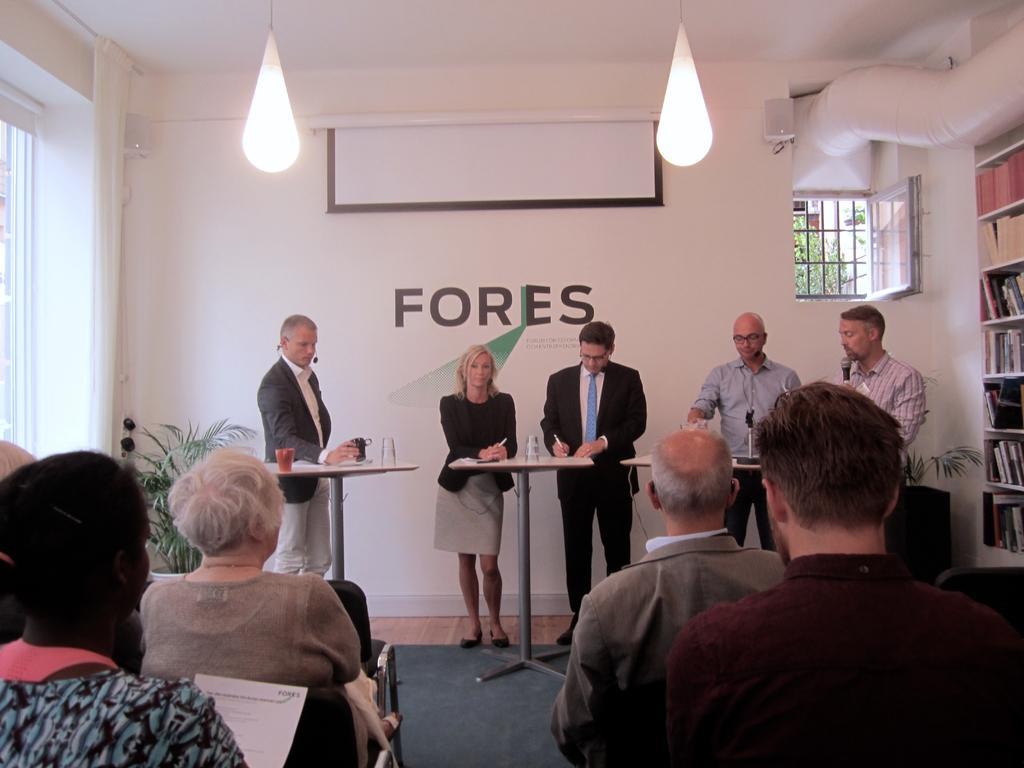In one or two sentences, can you explain what this image depicts? In this image, we can see people sitting on the chairs and one of them is holding a paper. In the background, there are people standing and are holding objects and we can see glasses, a cup and some other objects on the stands and there are books in the rack and we can see a window, a board with some text and there are lights and houseplants. At the bottom, there is a floor. 